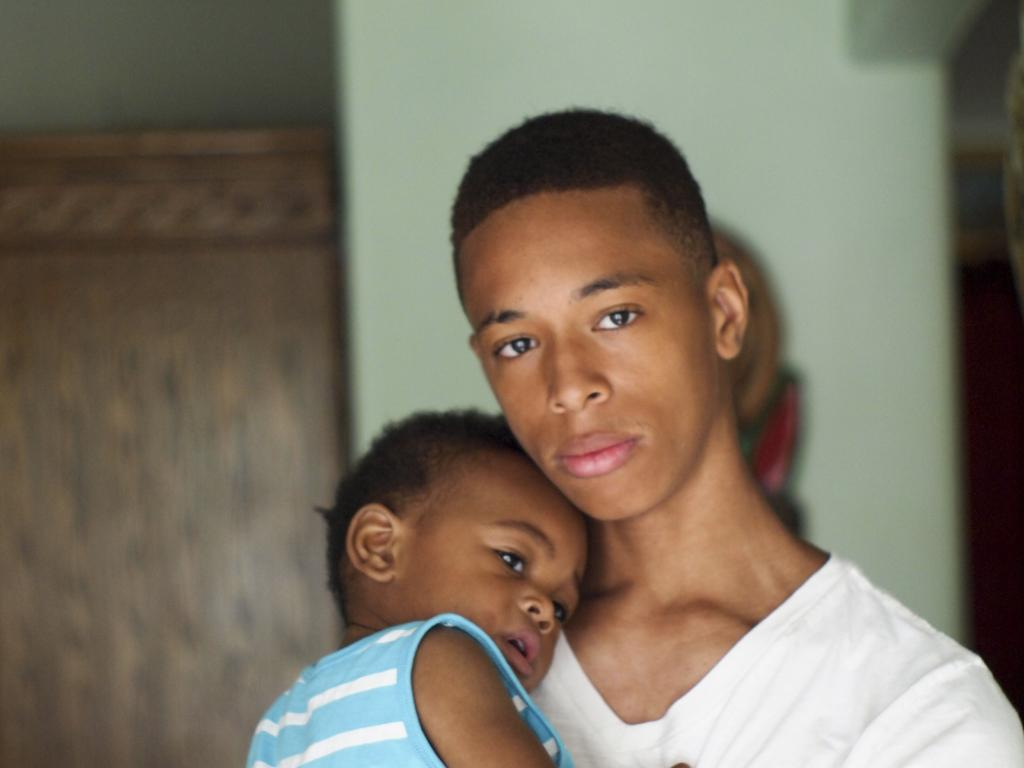What is the main subject of the close-up image? The main subject of the close-up image is a man and a baby. What can be observed about the man and baby in the image? The man and baby are wearing clothes. What can be seen in the background of the image? There is a wall visible in the background. How is the background of the image depicted? The background is blurred. What type of sidewalk can be seen in the image? There is no sidewalk present in the image; it features a close-up of a man and a baby with a blurred background. What is the man and baby eating for dinner in the image? There is no dinner depicted in the image; it is a close-up of a man and a baby with a blurred background. 